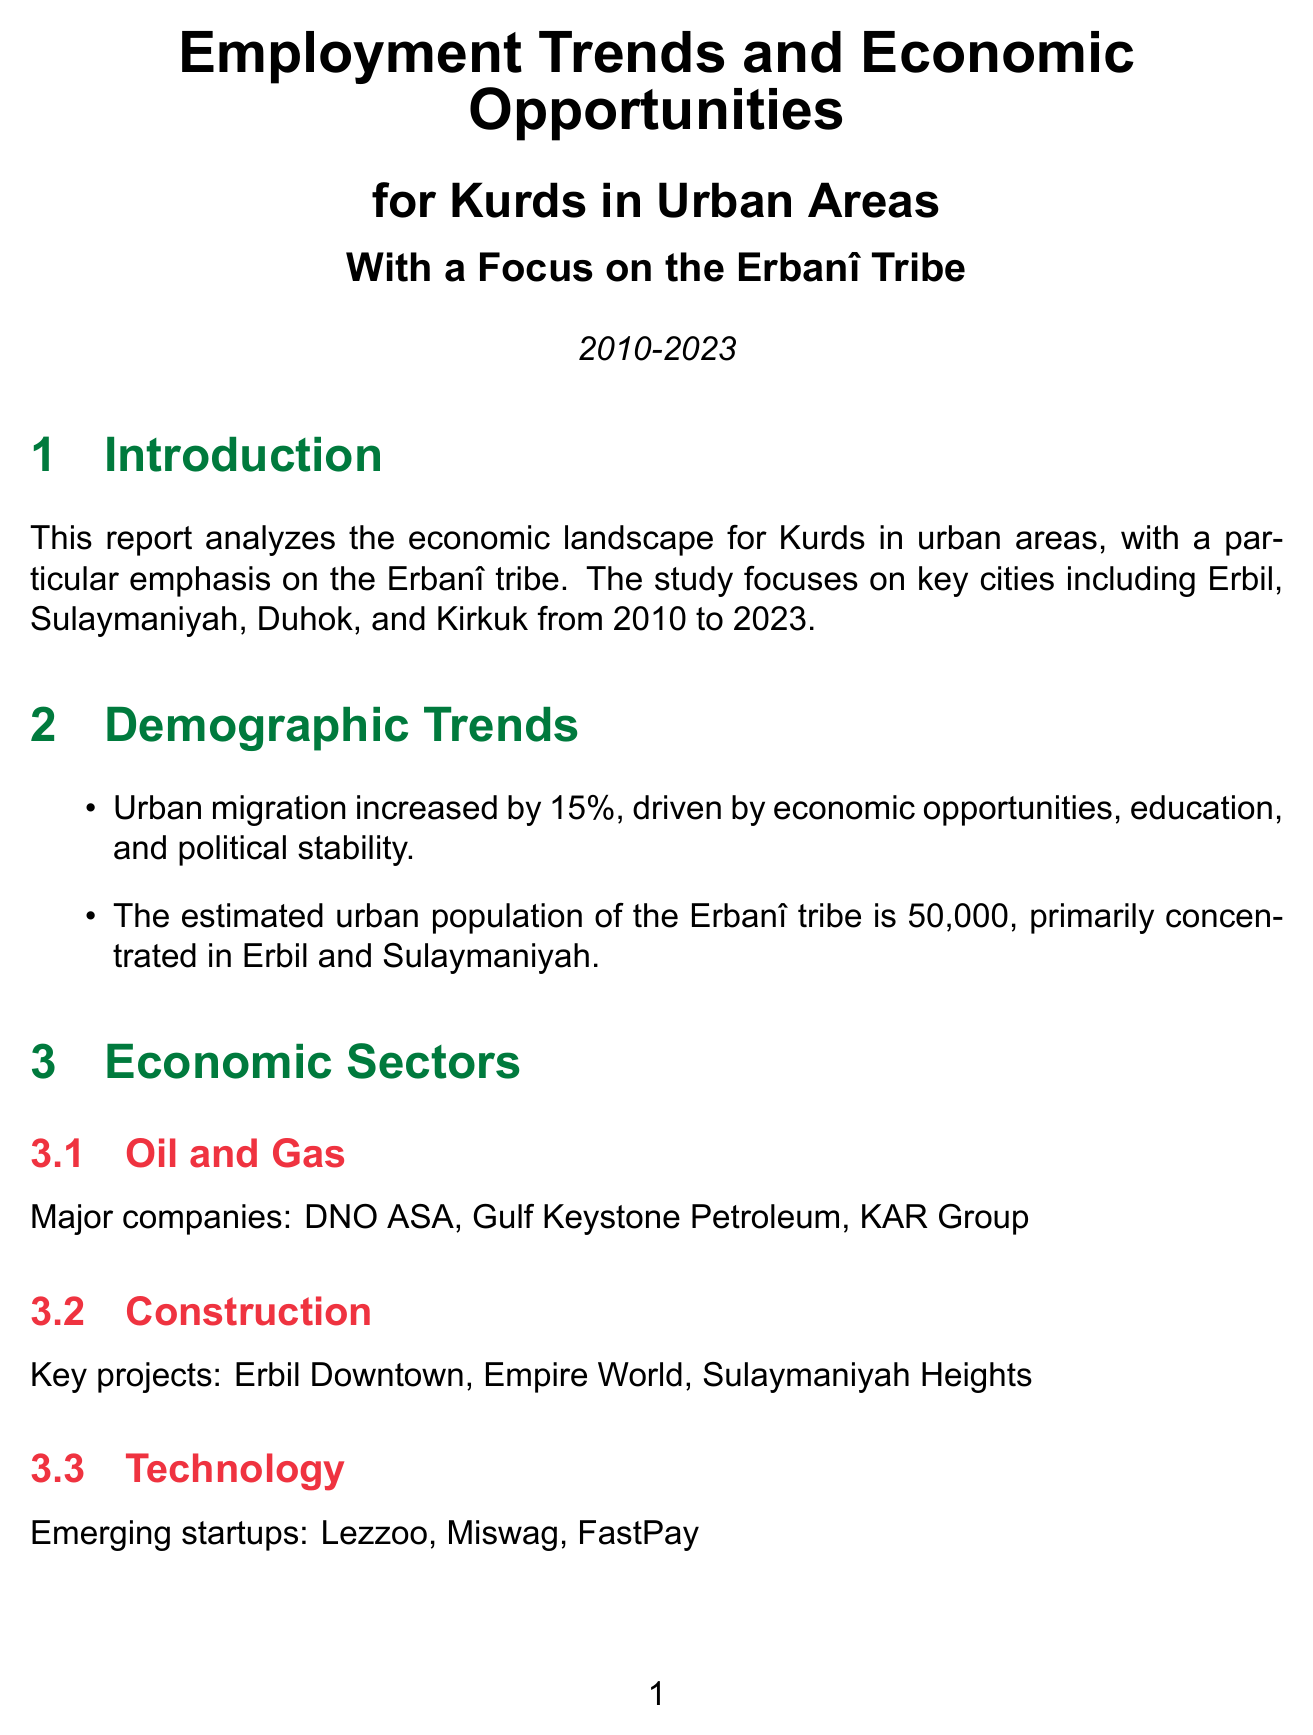what is the main focus of the report? The report focuses on the economic opportunities and employment trends specifically for the Erbanî tribe within urban areas.
Answer: Erbanî tribe how much did urban migration increase by? The document states that urban migration among the Erbanî tribe increased by 15%.
Answer: 15% what are the primary cities where the Erbanî population is concentrated? The primary cities mentioned for the Erbanî population are Erbil and Sulaymaniyah.
Answer: Erbil, Sulaymaniyah which sector has an 8% annual growth rate? The tourism sector is noted to have an 8% annual growth rate in the document.
Answer: tourism what percentage of jobs in urban development projects were filled by Erbanî tribe members? The document specifies that 12% of the jobs created by urban development projects were filled by Erbanî tribe members.
Answer: 12% what skills are focused on for future development? The document highlights the importance of digital literacy, sustainable development, and entrepreneurship for future skill development.
Answer: Digital literacy, Sustainable development, Entrepreneurship who is a tech entrepreneur mentioned in the report? Shvan Taha is identified as a notable tech entrepreneur in the report.
Answer: Shvan Taha what are the goals of the Kurdistan Vision 2030 initiative? The goals include diversifying the economy, improving education quality, and enhancing private sector growth.
Answer: Diversify economy, Improve education quality, Enhance private sector growth what is a major challenge faced according to the report? A significant challenge recognized in the document is regional instability, which leads to periodic economic disruptions.
Answer: regional instability 